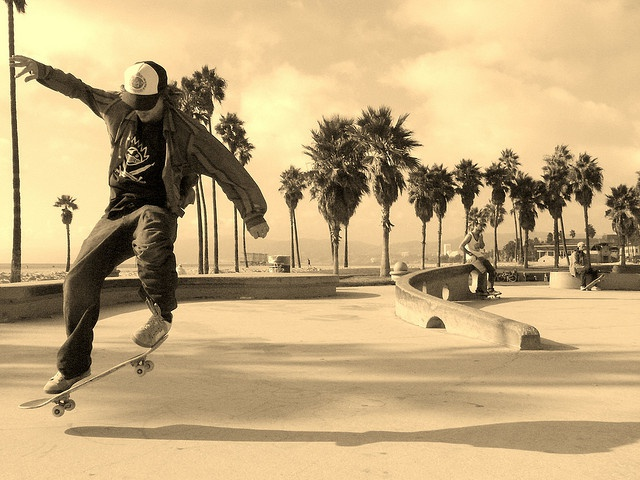Describe the objects in this image and their specific colors. I can see people in khaki, black, gray, and tan tones, people in khaki, black, tan, and gray tones, skateboard in khaki, tan, and gray tones, people in khaki, black, gray, and tan tones, and skateboard in khaki, black, and gray tones in this image. 